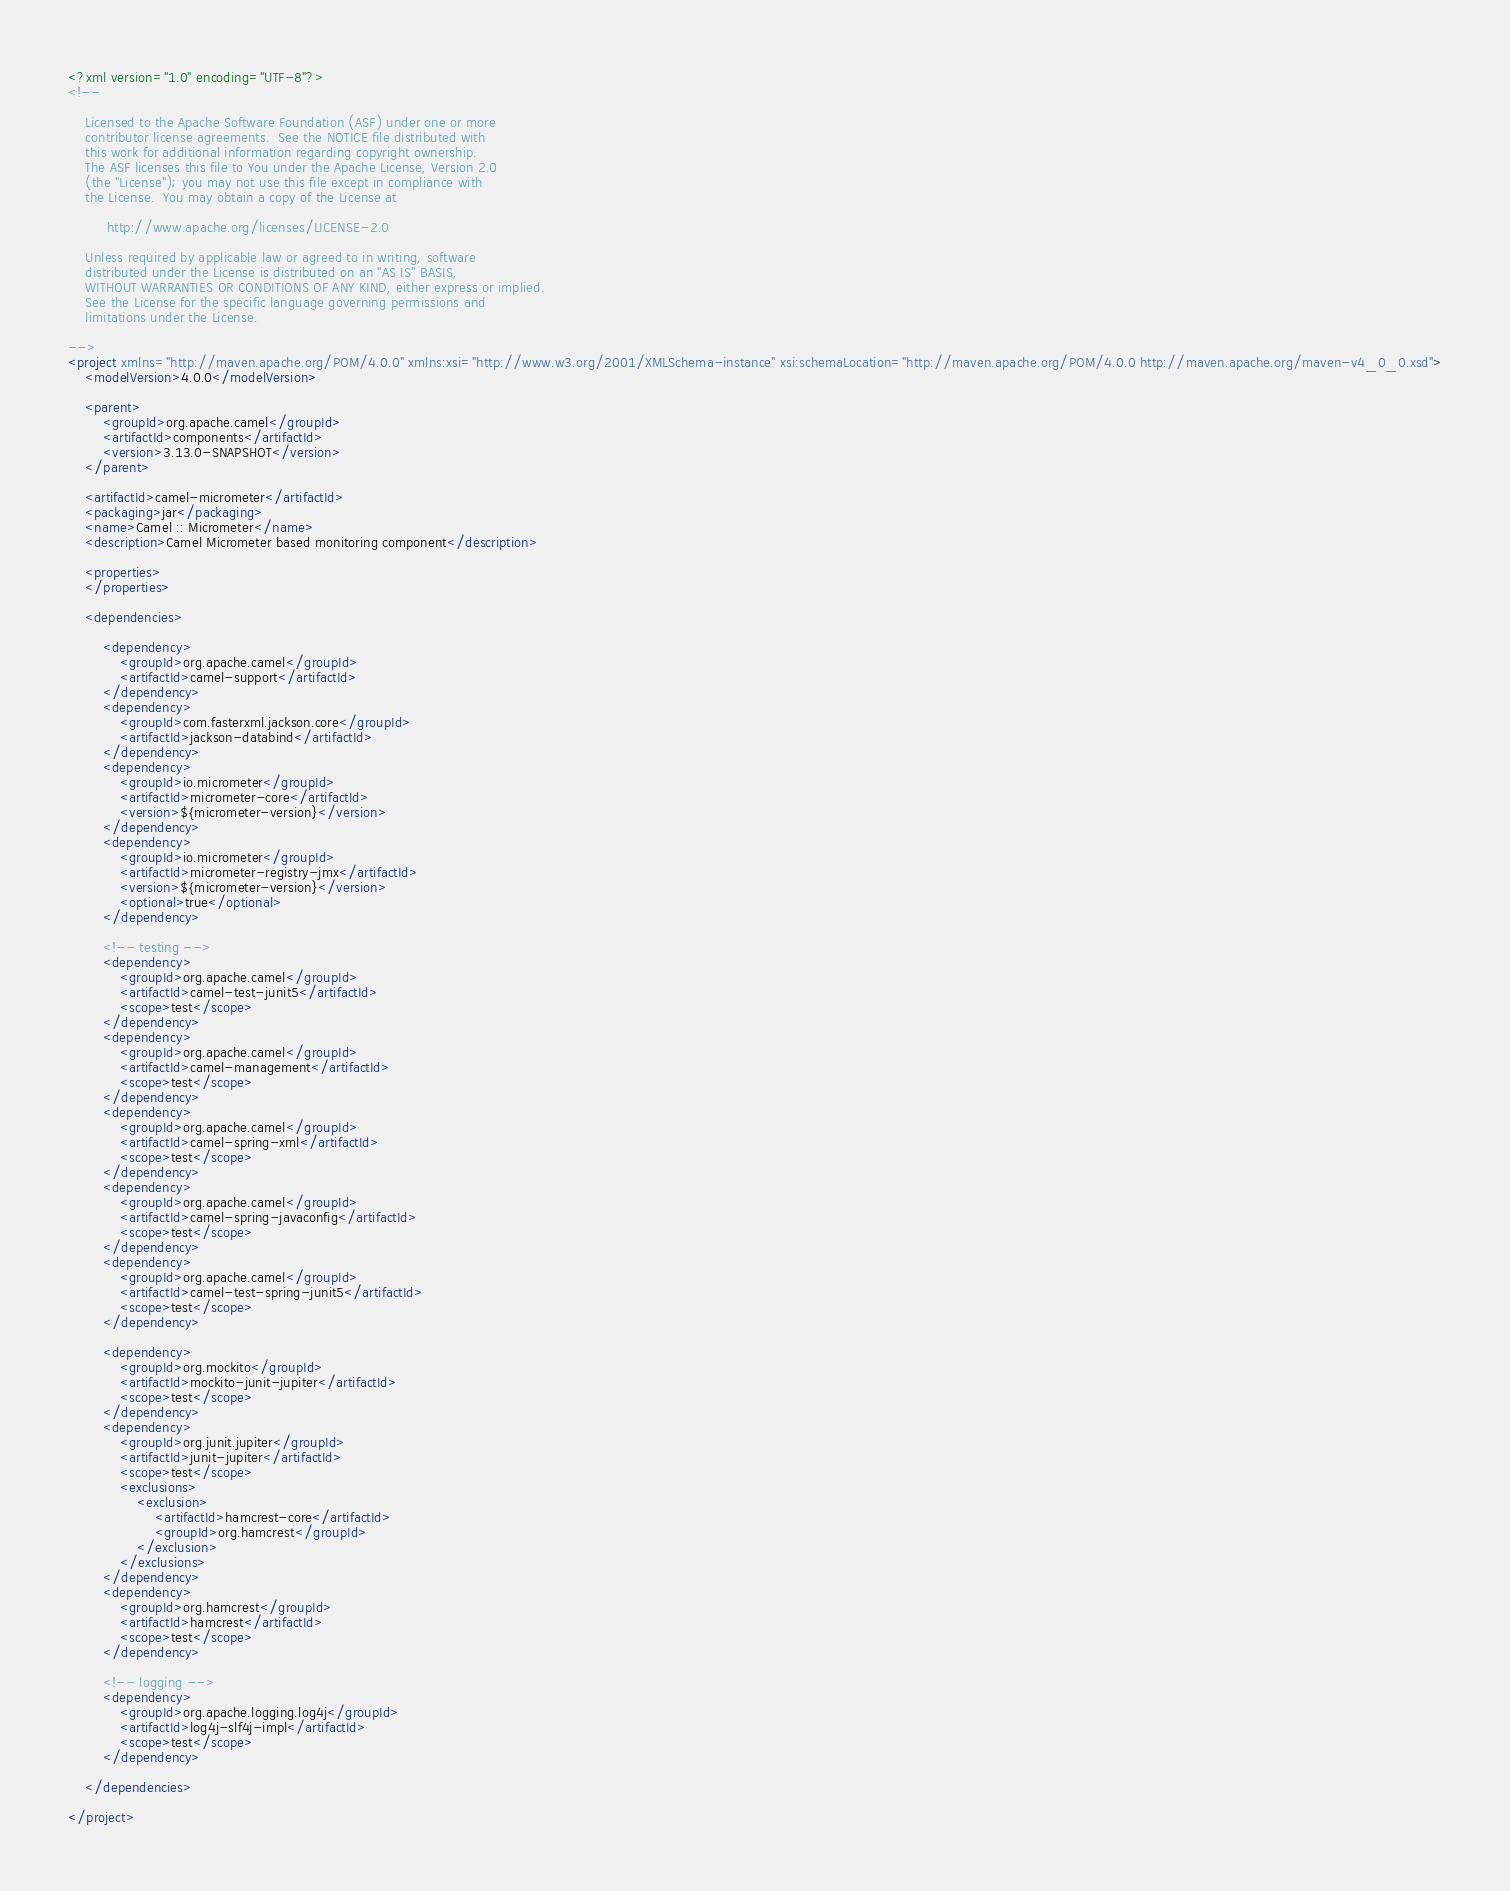<code> <loc_0><loc_0><loc_500><loc_500><_XML_><?xml version="1.0" encoding="UTF-8"?>
<!--

    Licensed to the Apache Software Foundation (ASF) under one or more
    contributor license agreements.  See the NOTICE file distributed with
    this work for additional information regarding copyright ownership.
    The ASF licenses this file to You under the Apache License, Version 2.0
    (the "License"); you may not use this file except in compliance with
    the License.  You may obtain a copy of the License at

         http://www.apache.org/licenses/LICENSE-2.0

    Unless required by applicable law or agreed to in writing, software
    distributed under the License is distributed on an "AS IS" BASIS,
    WITHOUT WARRANTIES OR CONDITIONS OF ANY KIND, either express or implied.
    See the License for the specific language governing permissions and
    limitations under the License.

-->
<project xmlns="http://maven.apache.org/POM/4.0.0" xmlns:xsi="http://www.w3.org/2001/XMLSchema-instance" xsi:schemaLocation="http://maven.apache.org/POM/4.0.0 http://maven.apache.org/maven-v4_0_0.xsd">
    <modelVersion>4.0.0</modelVersion>

    <parent>
        <groupId>org.apache.camel</groupId>
        <artifactId>components</artifactId>
        <version>3.13.0-SNAPSHOT</version>
    </parent>

    <artifactId>camel-micrometer</artifactId>
    <packaging>jar</packaging>
    <name>Camel :: Micrometer</name>
    <description>Camel Micrometer based monitoring component</description>

    <properties>
    </properties>

    <dependencies>

        <dependency>
            <groupId>org.apache.camel</groupId>
            <artifactId>camel-support</artifactId>
        </dependency>
        <dependency>
            <groupId>com.fasterxml.jackson.core</groupId>
            <artifactId>jackson-databind</artifactId>
        </dependency>
        <dependency>
            <groupId>io.micrometer</groupId>
            <artifactId>micrometer-core</artifactId>
            <version>${micrometer-version}</version>
        </dependency>
        <dependency>
            <groupId>io.micrometer</groupId>
            <artifactId>micrometer-registry-jmx</artifactId>
            <version>${micrometer-version}</version>
            <optional>true</optional>
        </dependency>

        <!-- testing -->
        <dependency>
            <groupId>org.apache.camel</groupId>
            <artifactId>camel-test-junit5</artifactId>
            <scope>test</scope>
        </dependency>
        <dependency>
            <groupId>org.apache.camel</groupId>
            <artifactId>camel-management</artifactId>
            <scope>test</scope>
        </dependency>
        <dependency>
            <groupId>org.apache.camel</groupId>
            <artifactId>camel-spring-xml</artifactId>
            <scope>test</scope>
        </dependency>
        <dependency>
            <groupId>org.apache.camel</groupId>
            <artifactId>camel-spring-javaconfig</artifactId>
            <scope>test</scope>
        </dependency>
        <dependency>
            <groupId>org.apache.camel</groupId>
            <artifactId>camel-test-spring-junit5</artifactId>
            <scope>test</scope>
        </dependency>

        <dependency>
            <groupId>org.mockito</groupId>
            <artifactId>mockito-junit-jupiter</artifactId>
            <scope>test</scope>
        </dependency>
        <dependency>
            <groupId>org.junit.jupiter</groupId>
            <artifactId>junit-jupiter</artifactId>
            <scope>test</scope>
            <exclusions>
                <exclusion>
                    <artifactId>hamcrest-core</artifactId>
                    <groupId>org.hamcrest</groupId>
                </exclusion>
            </exclusions>
        </dependency>
        <dependency>
            <groupId>org.hamcrest</groupId>
            <artifactId>hamcrest</artifactId>
            <scope>test</scope>
        </dependency>

        <!-- logging -->
        <dependency>
            <groupId>org.apache.logging.log4j</groupId>
            <artifactId>log4j-slf4j-impl</artifactId>
            <scope>test</scope>
        </dependency>

    </dependencies>

</project>
</code> 